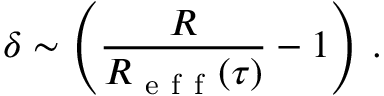Convert formula to latex. <formula><loc_0><loc_0><loc_500><loc_500>\delta \sim \left ( \frac { R } { R _ { e f f } ( \tau ) } - 1 \right ) \, .</formula> 